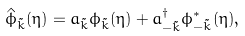Convert formula to latex. <formula><loc_0><loc_0><loc_500><loc_500>\hat { \phi } _ { \tilde { k } } ( \eta ) = a _ { \tilde { k } } \phi _ { \tilde { k } } ( \eta ) + a _ { - \tilde { k } } ^ { \dagger } \phi _ { - \tilde { k } } ^ { * } ( \eta ) ,</formula> 